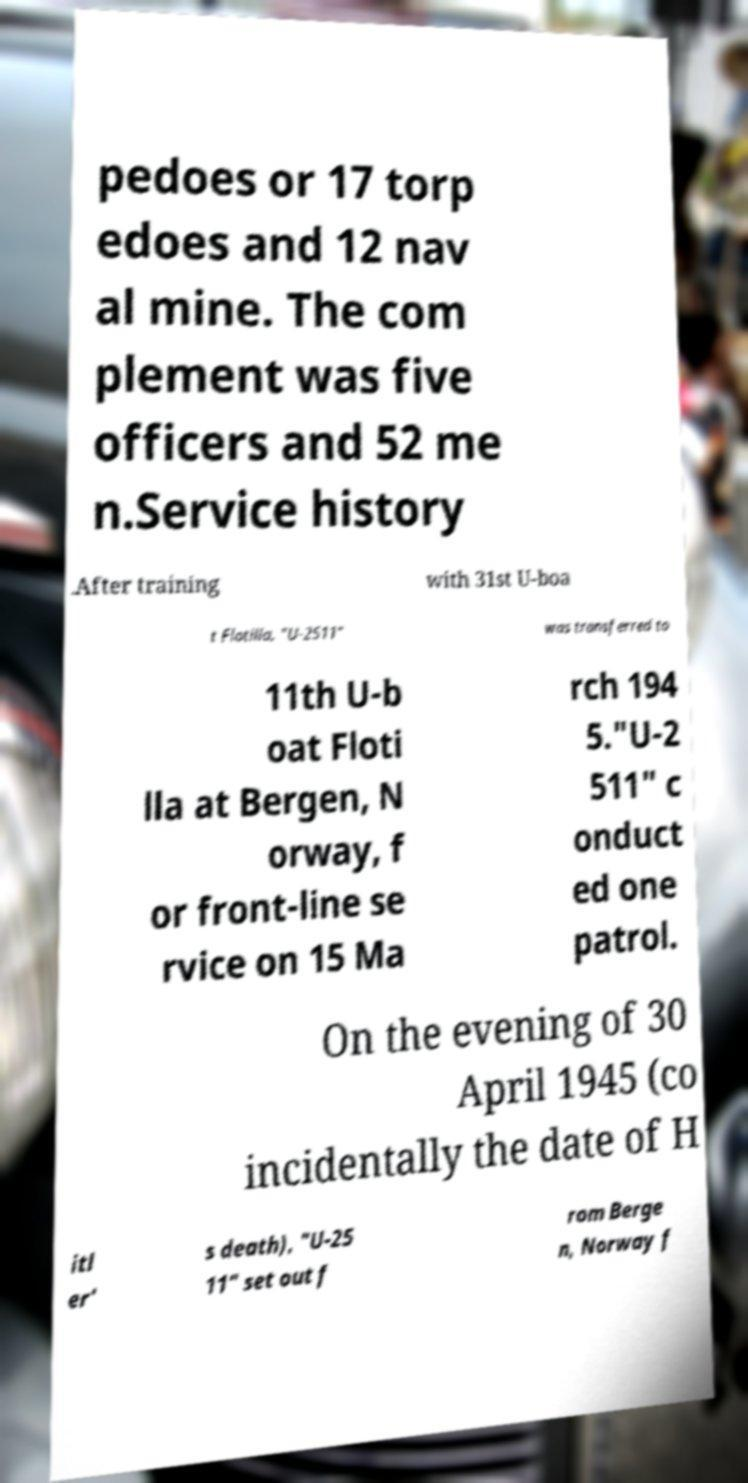I need the written content from this picture converted into text. Can you do that? pedoes or 17 torp edoes and 12 nav al mine. The com plement was five officers and 52 me n.Service history .After training with 31st U-boa t Flotilla, "U-2511" was transferred to 11th U-b oat Floti lla at Bergen, N orway, f or front-line se rvice on 15 Ma rch 194 5."U-2 511" c onduct ed one patrol. On the evening of 30 April 1945 (co incidentally the date of H itl er' s death), "U-25 11" set out f rom Berge n, Norway f 